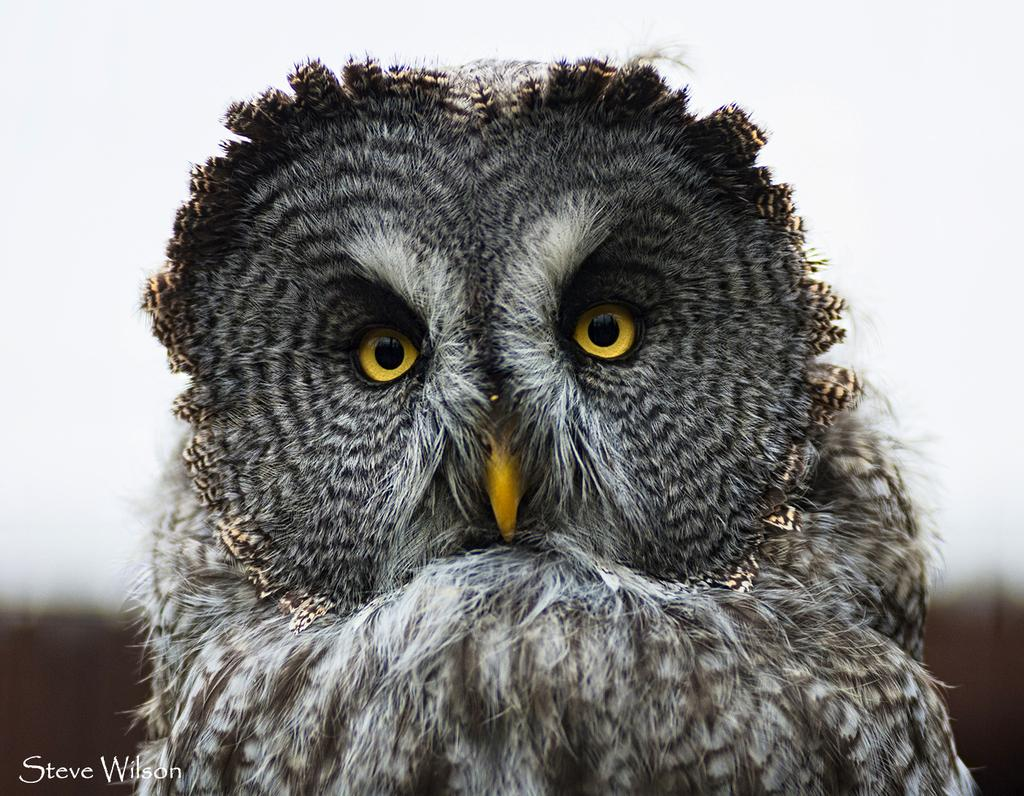What type of animal is in the image? There is an owl in the image. What colors can be seen on the owl? The owl has white, black, brown, and yellow colors. How would you describe the background of the image? The background of the image is blurry. What colors are present in the background? The background is white and black in color. What type of whip is being used by the owl in the image? There is no whip present in the image; it features an owl with specific colors and a blurry background. 